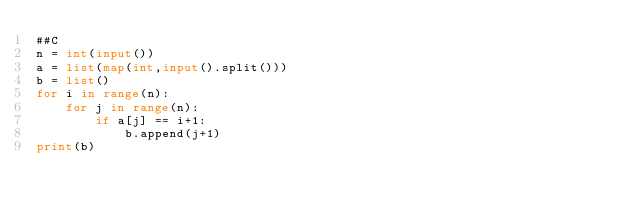<code> <loc_0><loc_0><loc_500><loc_500><_Python_>##C
n = int(input())
a = list(map(int,input().split()))
b = list()
for i in range(n):
    for j in range(n):
        if a[j] == i+1:
            b.append(j+1)
print(b)</code> 